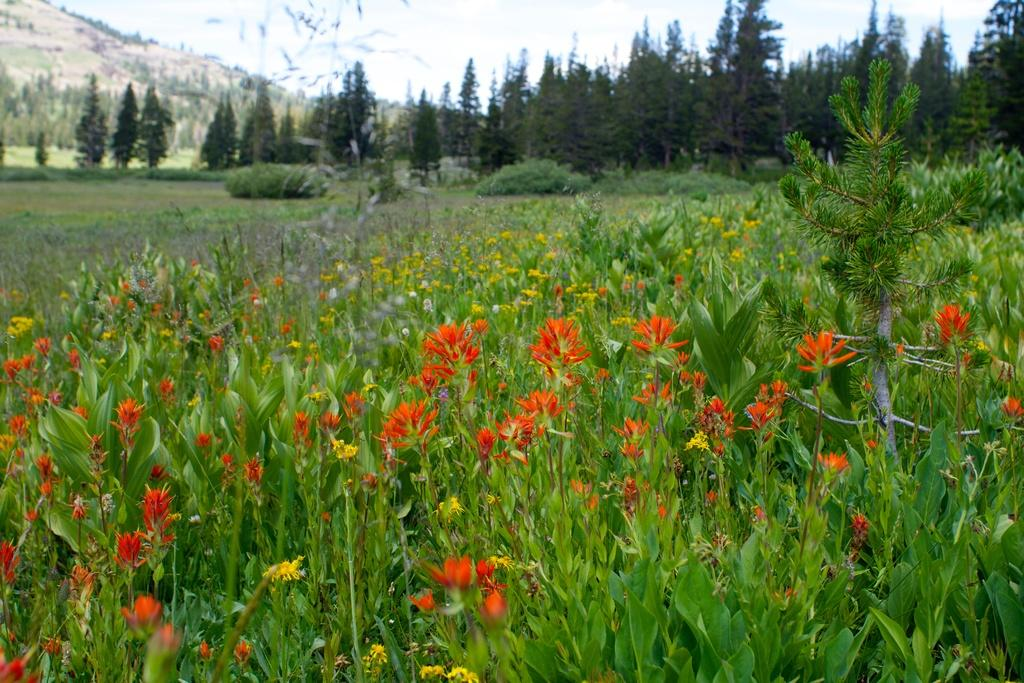What type of plants are in the image? The image contains flower plants. What can be seen on the left side of the image? There is a hill on the left side of the image. What type of grape is growing on the hill in the image? There is no grape plant or grapes visible in the image; it contains only flower plants. 